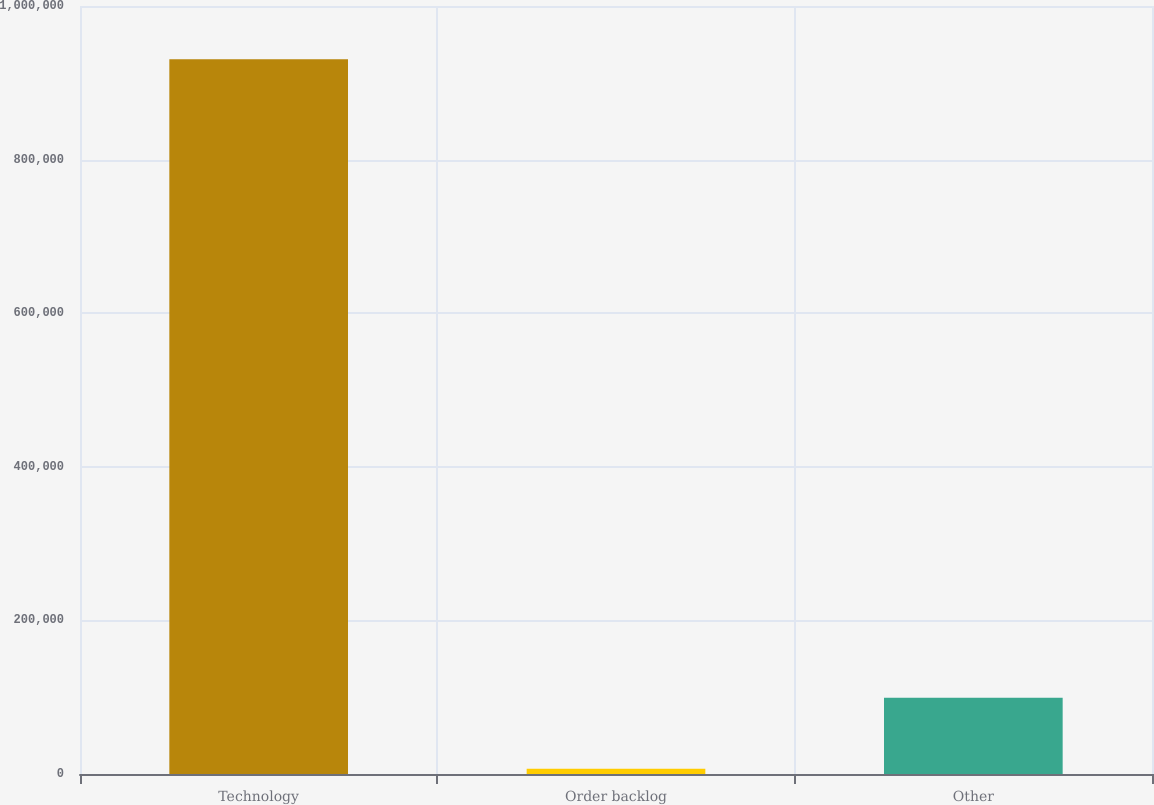Convert chart to OTSL. <chart><loc_0><loc_0><loc_500><loc_500><bar_chart><fcel>Technology<fcel>Order backlog<fcel>Other<nl><fcel>930735<fcel>6791<fcel>99185.4<nl></chart> 